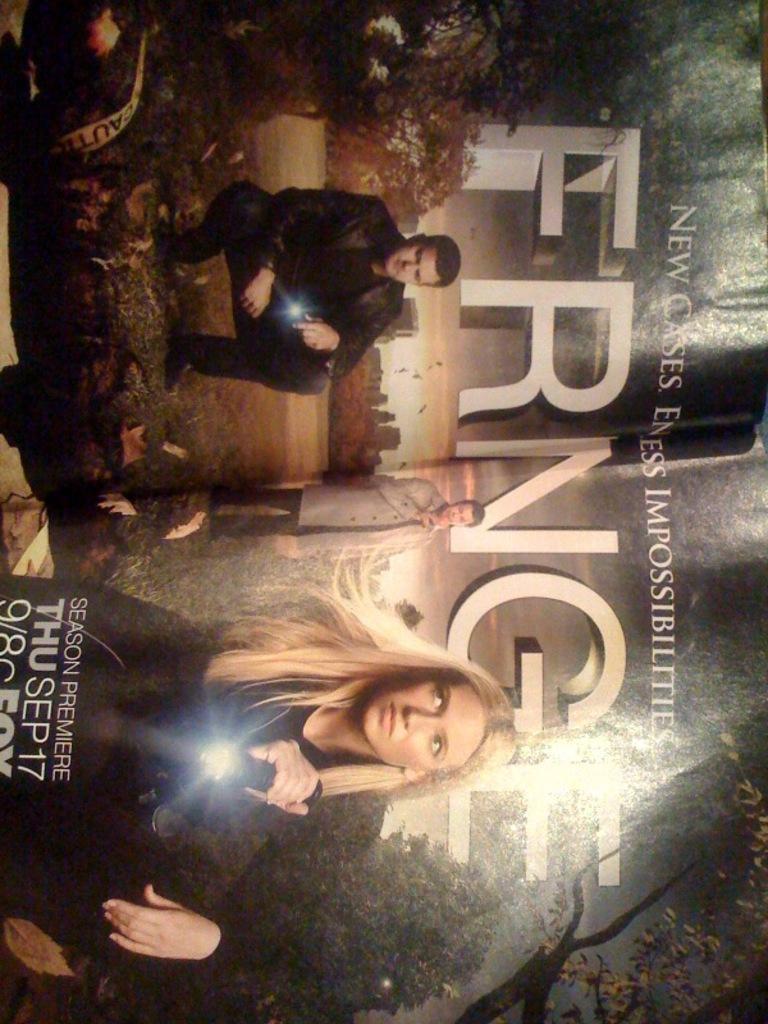Can you describe this image briefly? It is a poster. In this image there are people. At the bottom of the image there is grass on the surface. There are trees and there is some text on the image. 